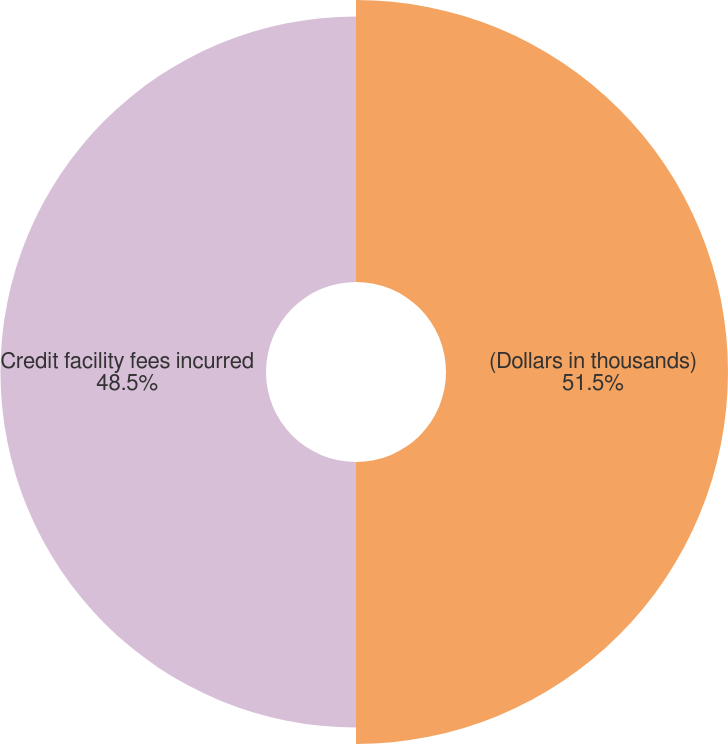Convert chart to OTSL. <chart><loc_0><loc_0><loc_500><loc_500><pie_chart><fcel>(Dollars in thousands)<fcel>Credit facility fees incurred<nl><fcel>51.5%<fcel>48.5%<nl></chart> 